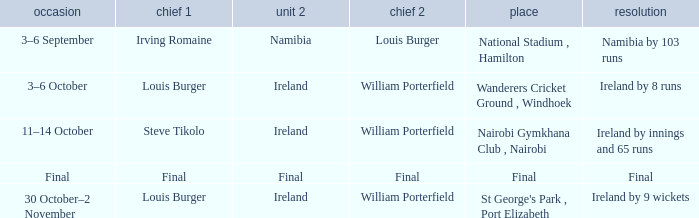Which Captain 2 has a Result of ireland by 8 runs? William Porterfield. 